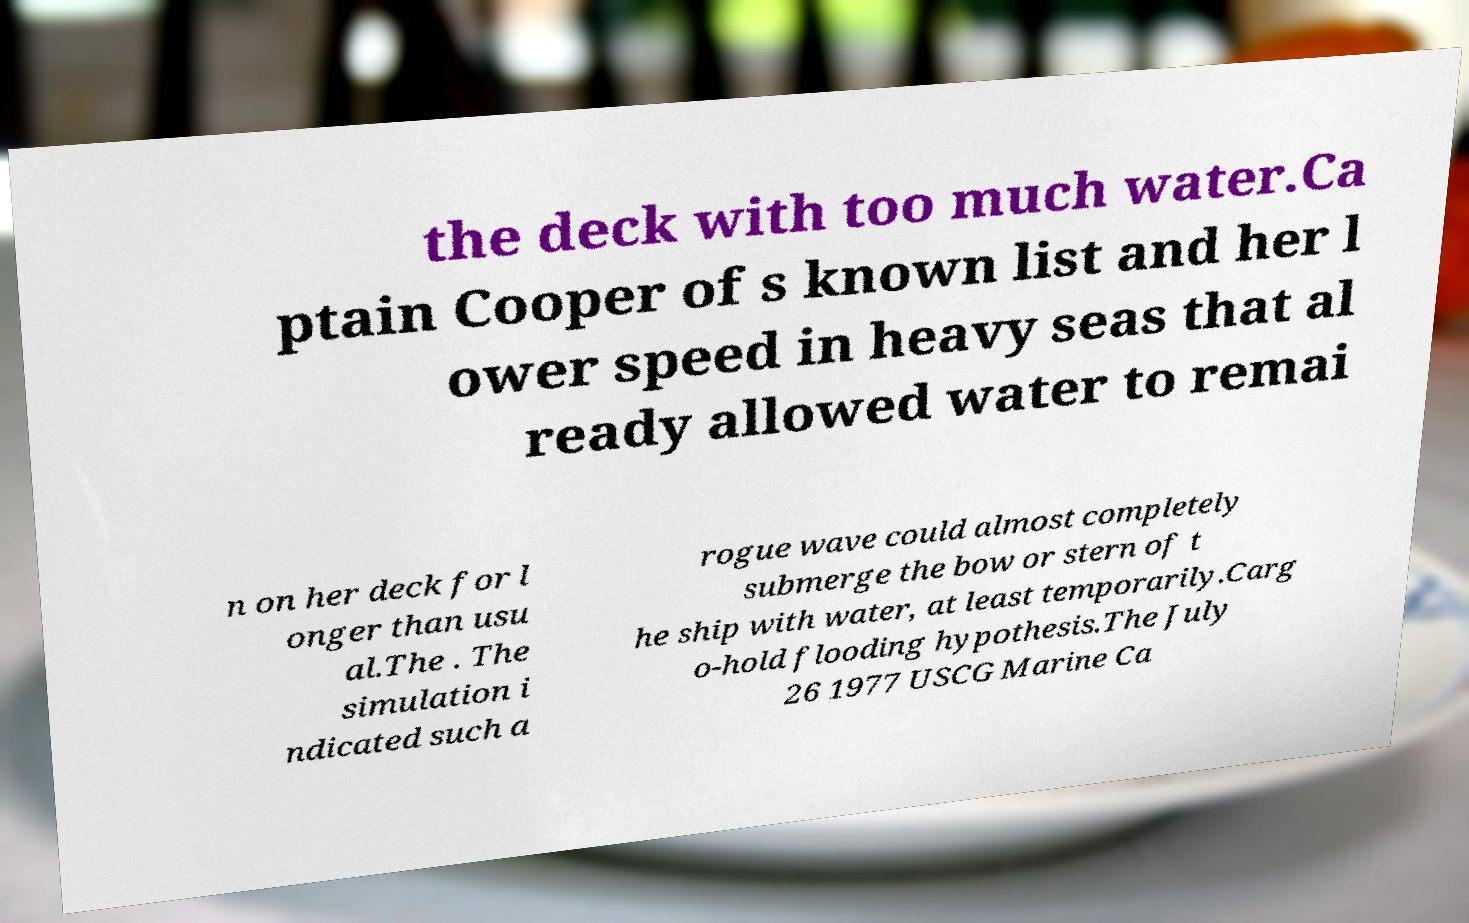There's text embedded in this image that I need extracted. Can you transcribe it verbatim? the deck with too much water.Ca ptain Cooper of s known list and her l ower speed in heavy seas that al ready allowed water to remai n on her deck for l onger than usu al.The . The simulation i ndicated such a rogue wave could almost completely submerge the bow or stern of t he ship with water, at least temporarily.Carg o-hold flooding hypothesis.The July 26 1977 USCG Marine Ca 